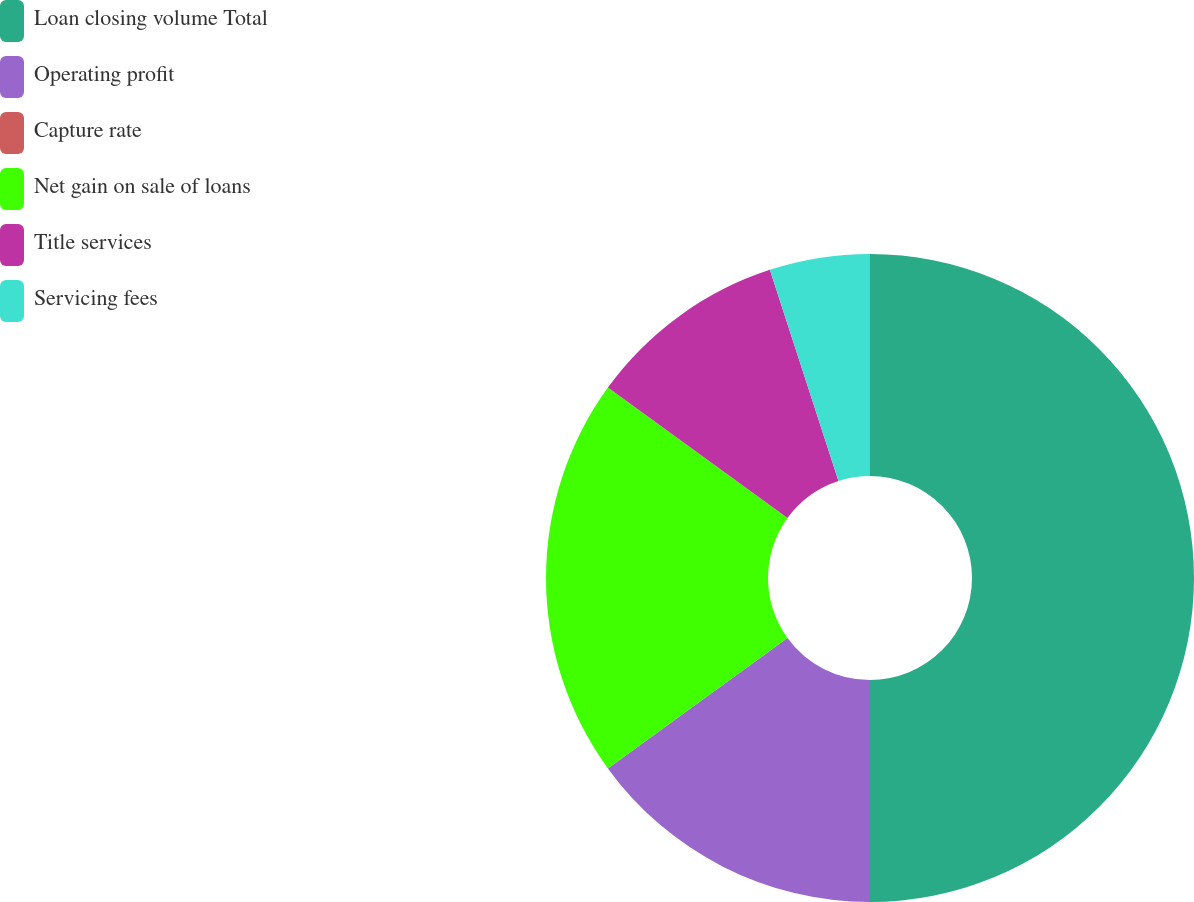<chart> <loc_0><loc_0><loc_500><loc_500><pie_chart><fcel>Loan closing volume Total<fcel>Operating profit<fcel>Capture rate<fcel>Net gain on sale of loans<fcel>Title services<fcel>Servicing fees<nl><fcel>50.0%<fcel>15.0%<fcel>0.0%<fcel>20.0%<fcel>10.0%<fcel>5.0%<nl></chart> 